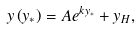<formula> <loc_0><loc_0><loc_500><loc_500>y \left ( y _ { \ast } \right ) = A e ^ { k y _ { \ast } } + y _ { H } ,</formula> 